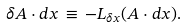Convert formula to latex. <formula><loc_0><loc_0><loc_500><loc_500>\delta A \cdot d x \, \equiv \, - { L } _ { \delta x } ( A \cdot d x ) .</formula> 